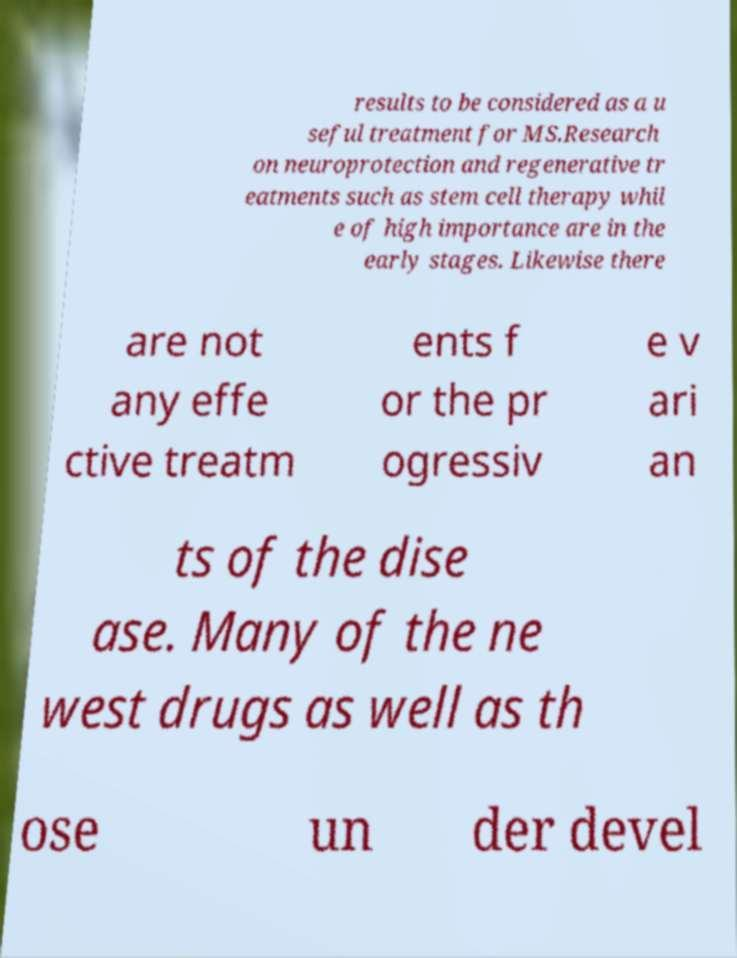What messages or text are displayed in this image? I need them in a readable, typed format. results to be considered as a u seful treatment for MS.Research on neuroprotection and regenerative tr eatments such as stem cell therapy whil e of high importance are in the early stages. Likewise there are not any effe ctive treatm ents f or the pr ogressiv e v ari an ts of the dise ase. Many of the ne west drugs as well as th ose un der devel 